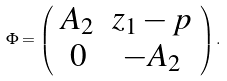<formula> <loc_0><loc_0><loc_500><loc_500>\Phi = \left ( \begin{array} { c c } A _ { 2 } & z _ { 1 } - p \\ 0 & - A _ { 2 } \end{array} \right ) .</formula> 